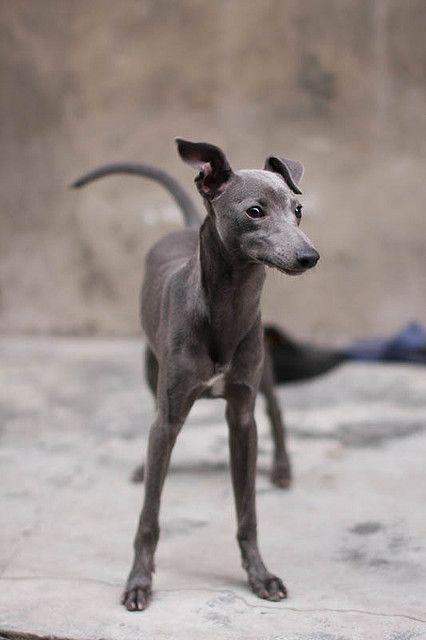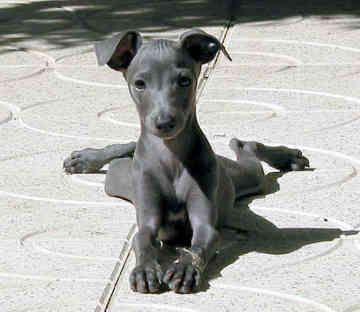The first image is the image on the left, the second image is the image on the right. Analyze the images presented: Is the assertion "Each Miniature Greyhound dog is standing on all four legs." valid? Answer yes or no. No. The first image is the image on the left, the second image is the image on the right. For the images shown, is this caption "An image shows a non-costumed dog with a black face and body, and white paws and chest." true? Answer yes or no. No. 